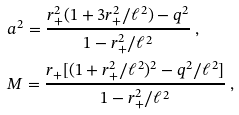<formula> <loc_0><loc_0><loc_500><loc_500>& a ^ { 2 } = \frac { r _ { + } ^ { 2 } ( 1 + 3 r _ { + } ^ { 2 } / \ell ^ { 2 } ) - q ^ { 2 } } { 1 - r _ { + } ^ { 2 } / \ell ^ { 2 } } \ , \\ & M = \frac { r _ { + } [ ( 1 + r _ { + } ^ { 2 } / \ell ^ { 2 } ) ^ { 2 } - q ^ { 2 } / \ell ^ { 2 } ] } { 1 - r _ { + } ^ { 2 } / \ell ^ { 2 } } \ ,</formula> 